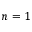<formula> <loc_0><loc_0><loc_500><loc_500>n = 1</formula> 